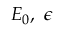<formula> <loc_0><loc_0><loc_500><loc_500>E _ { 0 } , \epsilon</formula> 